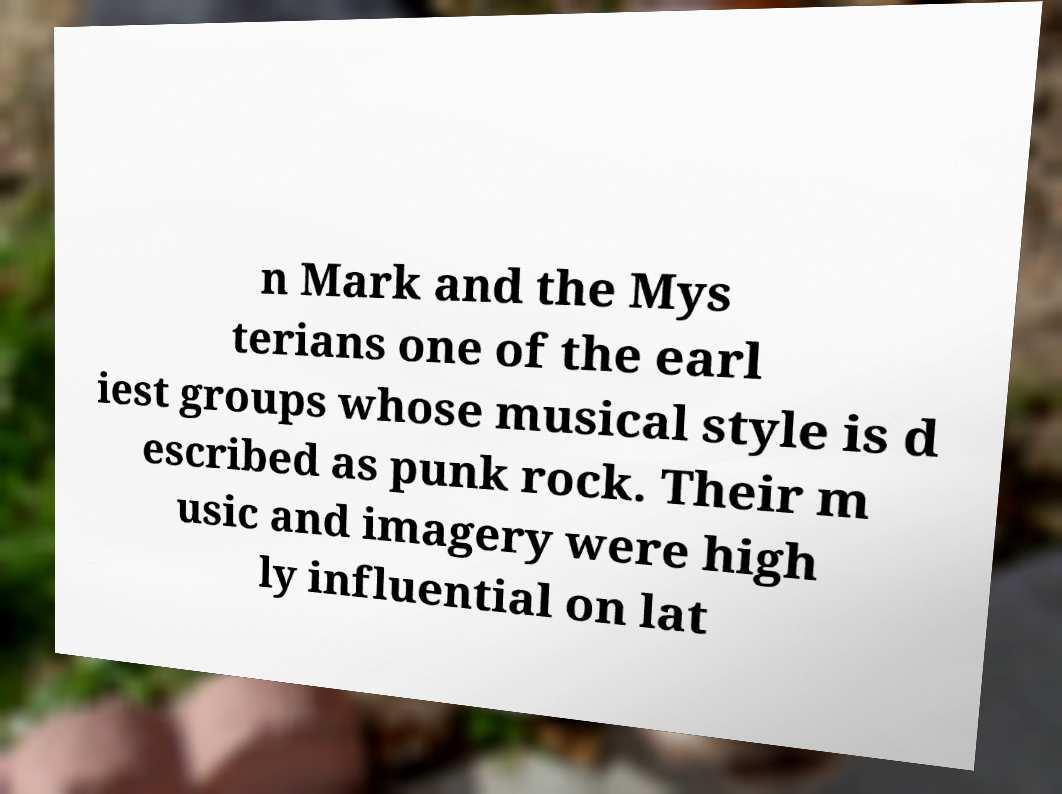I need the written content from this picture converted into text. Can you do that? n Mark and the Mys terians one of the earl iest groups whose musical style is d escribed as punk rock. Their m usic and imagery were high ly influential on lat 